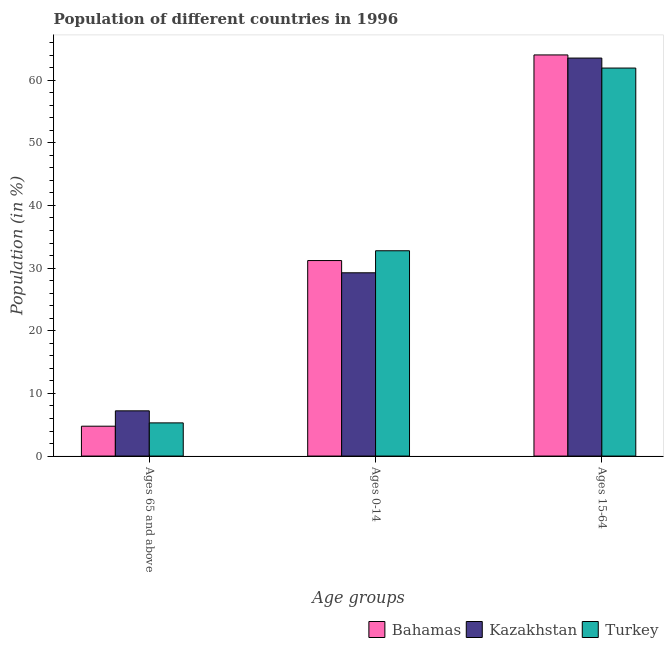How many different coloured bars are there?
Make the answer very short. 3. How many groups of bars are there?
Your answer should be very brief. 3. How many bars are there on the 1st tick from the left?
Your answer should be compact. 3. How many bars are there on the 3rd tick from the right?
Provide a succinct answer. 3. What is the label of the 2nd group of bars from the left?
Make the answer very short. Ages 0-14. What is the percentage of population within the age-group of 65 and above in Turkey?
Offer a very short reply. 5.3. Across all countries, what is the maximum percentage of population within the age-group 0-14?
Keep it short and to the point. 32.77. Across all countries, what is the minimum percentage of population within the age-group 0-14?
Give a very brief answer. 29.25. In which country was the percentage of population within the age-group of 65 and above maximum?
Keep it short and to the point. Kazakhstan. In which country was the percentage of population within the age-group 0-14 minimum?
Provide a succinct answer. Kazakhstan. What is the total percentage of population within the age-group 0-14 in the graph?
Give a very brief answer. 93.23. What is the difference between the percentage of population within the age-group 0-14 in Bahamas and that in Turkey?
Provide a succinct answer. -1.57. What is the difference between the percentage of population within the age-group 0-14 in Kazakhstan and the percentage of population within the age-group 15-64 in Turkey?
Provide a succinct answer. -32.68. What is the average percentage of population within the age-group 0-14 per country?
Give a very brief answer. 31.08. What is the difference between the percentage of population within the age-group 15-64 and percentage of population within the age-group of 65 and above in Turkey?
Give a very brief answer. 56.64. What is the ratio of the percentage of population within the age-group 0-14 in Kazakhstan to that in Bahamas?
Your response must be concise. 0.94. Is the percentage of population within the age-group of 65 and above in Turkey less than that in Kazakhstan?
Your answer should be compact. Yes. What is the difference between the highest and the second highest percentage of population within the age-group of 65 and above?
Provide a succinct answer. 1.92. What is the difference between the highest and the lowest percentage of population within the age-group 0-14?
Provide a short and direct response. 3.52. What does the 1st bar from the right in Ages 0-14 represents?
Keep it short and to the point. Turkey. How many countries are there in the graph?
Your response must be concise. 3. What is the difference between two consecutive major ticks on the Y-axis?
Provide a short and direct response. 10. Does the graph contain any zero values?
Make the answer very short. No. Does the graph contain grids?
Your answer should be very brief. No. How many legend labels are there?
Give a very brief answer. 3. How are the legend labels stacked?
Offer a very short reply. Horizontal. What is the title of the graph?
Your response must be concise. Population of different countries in 1996. Does "United Kingdom" appear as one of the legend labels in the graph?
Ensure brevity in your answer.  No. What is the label or title of the X-axis?
Provide a short and direct response. Age groups. What is the Population (in %) in Bahamas in Ages 65 and above?
Your answer should be compact. 4.77. What is the Population (in %) of Kazakhstan in Ages 65 and above?
Ensure brevity in your answer.  7.22. What is the Population (in %) in Turkey in Ages 65 and above?
Give a very brief answer. 5.3. What is the Population (in %) of Bahamas in Ages 0-14?
Your answer should be very brief. 31.21. What is the Population (in %) in Kazakhstan in Ages 0-14?
Your answer should be very brief. 29.25. What is the Population (in %) of Turkey in Ages 0-14?
Give a very brief answer. 32.77. What is the Population (in %) of Bahamas in Ages 15-64?
Your answer should be compact. 64.03. What is the Population (in %) in Kazakhstan in Ages 15-64?
Provide a succinct answer. 63.53. What is the Population (in %) in Turkey in Ages 15-64?
Offer a terse response. 61.93. Across all Age groups, what is the maximum Population (in %) of Bahamas?
Provide a short and direct response. 64.03. Across all Age groups, what is the maximum Population (in %) in Kazakhstan?
Offer a terse response. 63.53. Across all Age groups, what is the maximum Population (in %) in Turkey?
Ensure brevity in your answer.  61.93. Across all Age groups, what is the minimum Population (in %) in Bahamas?
Keep it short and to the point. 4.77. Across all Age groups, what is the minimum Population (in %) of Kazakhstan?
Give a very brief answer. 7.22. Across all Age groups, what is the minimum Population (in %) in Turkey?
Your response must be concise. 5.3. What is the total Population (in %) of Bahamas in the graph?
Offer a very short reply. 100. What is the total Population (in %) of Kazakhstan in the graph?
Your answer should be compact. 100. What is the difference between the Population (in %) of Bahamas in Ages 65 and above and that in Ages 0-14?
Your answer should be compact. -26.44. What is the difference between the Population (in %) in Kazakhstan in Ages 65 and above and that in Ages 0-14?
Offer a terse response. -22.03. What is the difference between the Population (in %) in Turkey in Ages 65 and above and that in Ages 0-14?
Offer a terse response. -27.47. What is the difference between the Population (in %) of Bahamas in Ages 65 and above and that in Ages 15-64?
Ensure brevity in your answer.  -59.26. What is the difference between the Population (in %) of Kazakhstan in Ages 65 and above and that in Ages 15-64?
Make the answer very short. -56.31. What is the difference between the Population (in %) of Turkey in Ages 65 and above and that in Ages 15-64?
Make the answer very short. -56.64. What is the difference between the Population (in %) in Bahamas in Ages 0-14 and that in Ages 15-64?
Offer a terse response. -32.82. What is the difference between the Population (in %) of Kazakhstan in Ages 0-14 and that in Ages 15-64?
Keep it short and to the point. -34.27. What is the difference between the Population (in %) in Turkey in Ages 0-14 and that in Ages 15-64?
Your answer should be very brief. -29.16. What is the difference between the Population (in %) in Bahamas in Ages 65 and above and the Population (in %) in Kazakhstan in Ages 0-14?
Give a very brief answer. -24.49. What is the difference between the Population (in %) of Bahamas in Ages 65 and above and the Population (in %) of Turkey in Ages 0-14?
Give a very brief answer. -28. What is the difference between the Population (in %) of Kazakhstan in Ages 65 and above and the Population (in %) of Turkey in Ages 0-14?
Your answer should be compact. -25.55. What is the difference between the Population (in %) of Bahamas in Ages 65 and above and the Population (in %) of Kazakhstan in Ages 15-64?
Provide a succinct answer. -58.76. What is the difference between the Population (in %) of Bahamas in Ages 65 and above and the Population (in %) of Turkey in Ages 15-64?
Provide a short and direct response. -57.17. What is the difference between the Population (in %) of Kazakhstan in Ages 65 and above and the Population (in %) of Turkey in Ages 15-64?
Keep it short and to the point. -54.71. What is the difference between the Population (in %) of Bahamas in Ages 0-14 and the Population (in %) of Kazakhstan in Ages 15-64?
Your answer should be very brief. -32.32. What is the difference between the Population (in %) in Bahamas in Ages 0-14 and the Population (in %) in Turkey in Ages 15-64?
Provide a short and direct response. -30.73. What is the difference between the Population (in %) of Kazakhstan in Ages 0-14 and the Population (in %) of Turkey in Ages 15-64?
Ensure brevity in your answer.  -32.68. What is the average Population (in %) in Bahamas per Age groups?
Your answer should be compact. 33.33. What is the average Population (in %) of Kazakhstan per Age groups?
Give a very brief answer. 33.33. What is the average Population (in %) in Turkey per Age groups?
Your answer should be compact. 33.33. What is the difference between the Population (in %) in Bahamas and Population (in %) in Kazakhstan in Ages 65 and above?
Provide a short and direct response. -2.45. What is the difference between the Population (in %) in Bahamas and Population (in %) in Turkey in Ages 65 and above?
Provide a succinct answer. -0.53. What is the difference between the Population (in %) of Kazakhstan and Population (in %) of Turkey in Ages 65 and above?
Your response must be concise. 1.92. What is the difference between the Population (in %) of Bahamas and Population (in %) of Kazakhstan in Ages 0-14?
Keep it short and to the point. 1.95. What is the difference between the Population (in %) in Bahamas and Population (in %) in Turkey in Ages 0-14?
Offer a terse response. -1.56. What is the difference between the Population (in %) of Kazakhstan and Population (in %) of Turkey in Ages 0-14?
Provide a succinct answer. -3.52. What is the difference between the Population (in %) in Bahamas and Population (in %) in Kazakhstan in Ages 15-64?
Make the answer very short. 0.5. What is the difference between the Population (in %) in Bahamas and Population (in %) in Turkey in Ages 15-64?
Your answer should be very brief. 2.09. What is the difference between the Population (in %) of Kazakhstan and Population (in %) of Turkey in Ages 15-64?
Provide a short and direct response. 1.59. What is the ratio of the Population (in %) in Bahamas in Ages 65 and above to that in Ages 0-14?
Provide a short and direct response. 0.15. What is the ratio of the Population (in %) in Kazakhstan in Ages 65 and above to that in Ages 0-14?
Your answer should be compact. 0.25. What is the ratio of the Population (in %) in Turkey in Ages 65 and above to that in Ages 0-14?
Make the answer very short. 0.16. What is the ratio of the Population (in %) in Bahamas in Ages 65 and above to that in Ages 15-64?
Offer a very short reply. 0.07. What is the ratio of the Population (in %) in Kazakhstan in Ages 65 and above to that in Ages 15-64?
Provide a short and direct response. 0.11. What is the ratio of the Population (in %) of Turkey in Ages 65 and above to that in Ages 15-64?
Give a very brief answer. 0.09. What is the ratio of the Population (in %) of Bahamas in Ages 0-14 to that in Ages 15-64?
Offer a very short reply. 0.49. What is the ratio of the Population (in %) of Kazakhstan in Ages 0-14 to that in Ages 15-64?
Offer a terse response. 0.46. What is the ratio of the Population (in %) in Turkey in Ages 0-14 to that in Ages 15-64?
Your response must be concise. 0.53. What is the difference between the highest and the second highest Population (in %) of Bahamas?
Offer a very short reply. 32.82. What is the difference between the highest and the second highest Population (in %) of Kazakhstan?
Make the answer very short. 34.27. What is the difference between the highest and the second highest Population (in %) of Turkey?
Give a very brief answer. 29.16. What is the difference between the highest and the lowest Population (in %) of Bahamas?
Your response must be concise. 59.26. What is the difference between the highest and the lowest Population (in %) in Kazakhstan?
Keep it short and to the point. 56.31. What is the difference between the highest and the lowest Population (in %) in Turkey?
Provide a short and direct response. 56.64. 